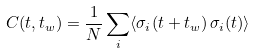<formula> <loc_0><loc_0><loc_500><loc_500>C ( t , t _ { w } ) = \frac { 1 } { N } \sum _ { i } \langle \sigma _ { i } ( t + t _ { w } ) \, \sigma _ { i } ( t ) \rangle</formula> 